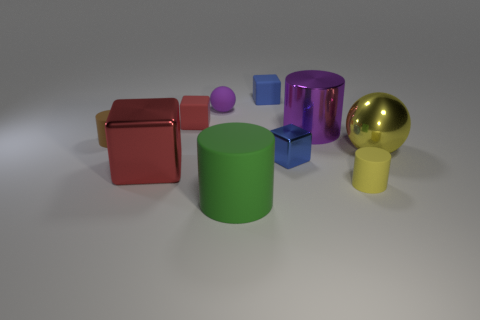Which object in the image appears to be the largest? The red cube appears to be the largest object in the image. What could be the use of the smallest blue cube? The smallest blue cube might be a child's building block or a decorative piece. 